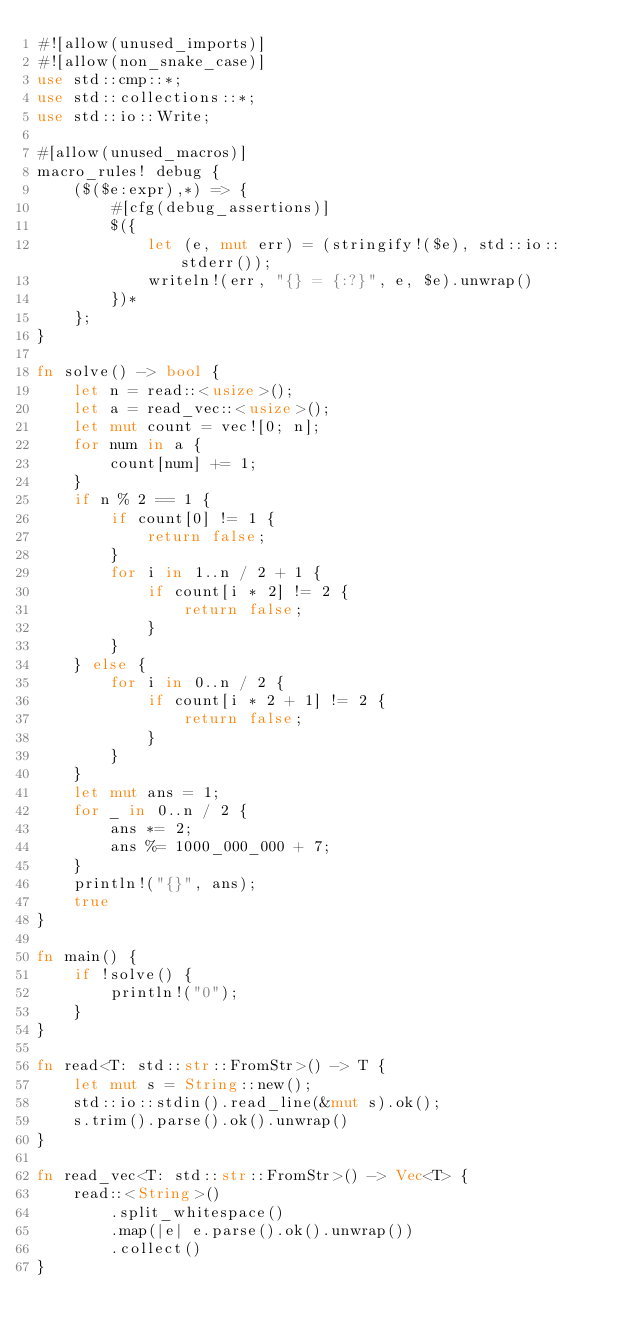Convert code to text. <code><loc_0><loc_0><loc_500><loc_500><_Rust_>#![allow(unused_imports)]
#![allow(non_snake_case)]
use std::cmp::*;
use std::collections::*;
use std::io::Write;

#[allow(unused_macros)]
macro_rules! debug {
    ($($e:expr),*) => {
        #[cfg(debug_assertions)]
        $({
            let (e, mut err) = (stringify!($e), std::io::stderr());
            writeln!(err, "{} = {:?}", e, $e).unwrap()
        })*
    };
}

fn solve() -> bool {
    let n = read::<usize>();
    let a = read_vec::<usize>();
    let mut count = vec![0; n];
    for num in a {
        count[num] += 1;
    }
    if n % 2 == 1 {
        if count[0] != 1 {
            return false;
        }
        for i in 1..n / 2 + 1 {
            if count[i * 2] != 2 {
                return false;
            }
        }
    } else {
        for i in 0..n / 2 {
            if count[i * 2 + 1] != 2 {
                return false;
            }
        }
    }
    let mut ans = 1;
    for _ in 0..n / 2 {
        ans *= 2;
        ans %= 1000_000_000 + 7;
    }
    println!("{}", ans);
    true
}

fn main() {
    if !solve() {
        println!("0");
    }
}

fn read<T: std::str::FromStr>() -> T {
    let mut s = String::new();
    std::io::stdin().read_line(&mut s).ok();
    s.trim().parse().ok().unwrap()
}

fn read_vec<T: std::str::FromStr>() -> Vec<T> {
    read::<String>()
        .split_whitespace()
        .map(|e| e.parse().ok().unwrap())
        .collect()
}
</code> 